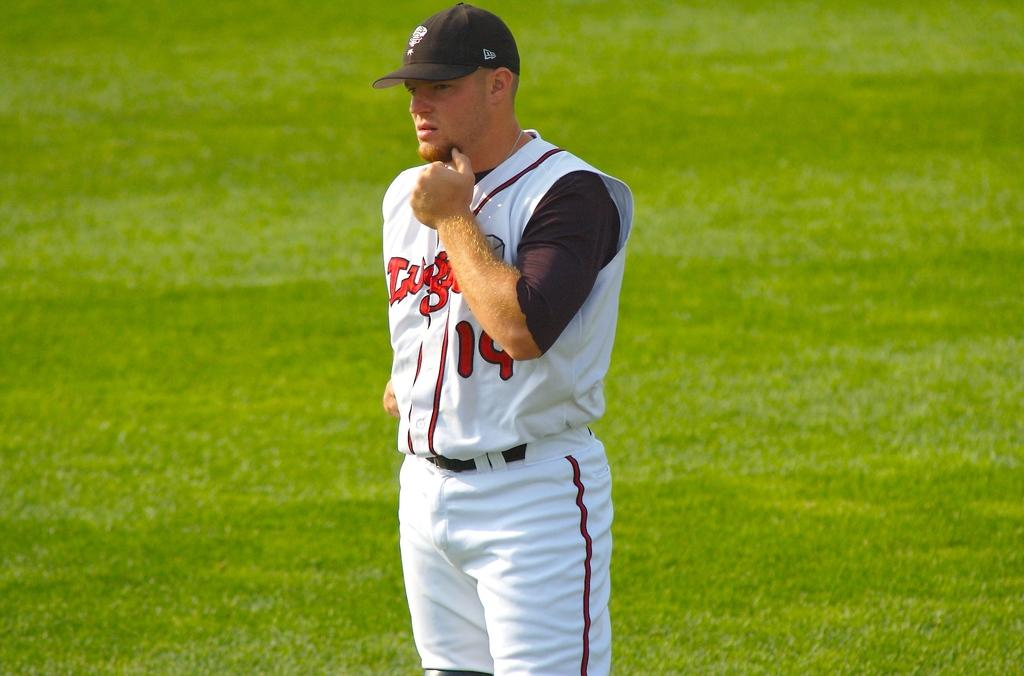<image>
Provide a brief description of the given image. A baseball player in a white uniform with the number 19 in red. 